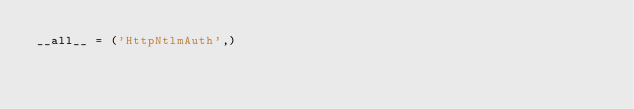<code> <loc_0><loc_0><loc_500><loc_500><_Python_>__all__ = ('HttpNtlmAuth',)
</code> 